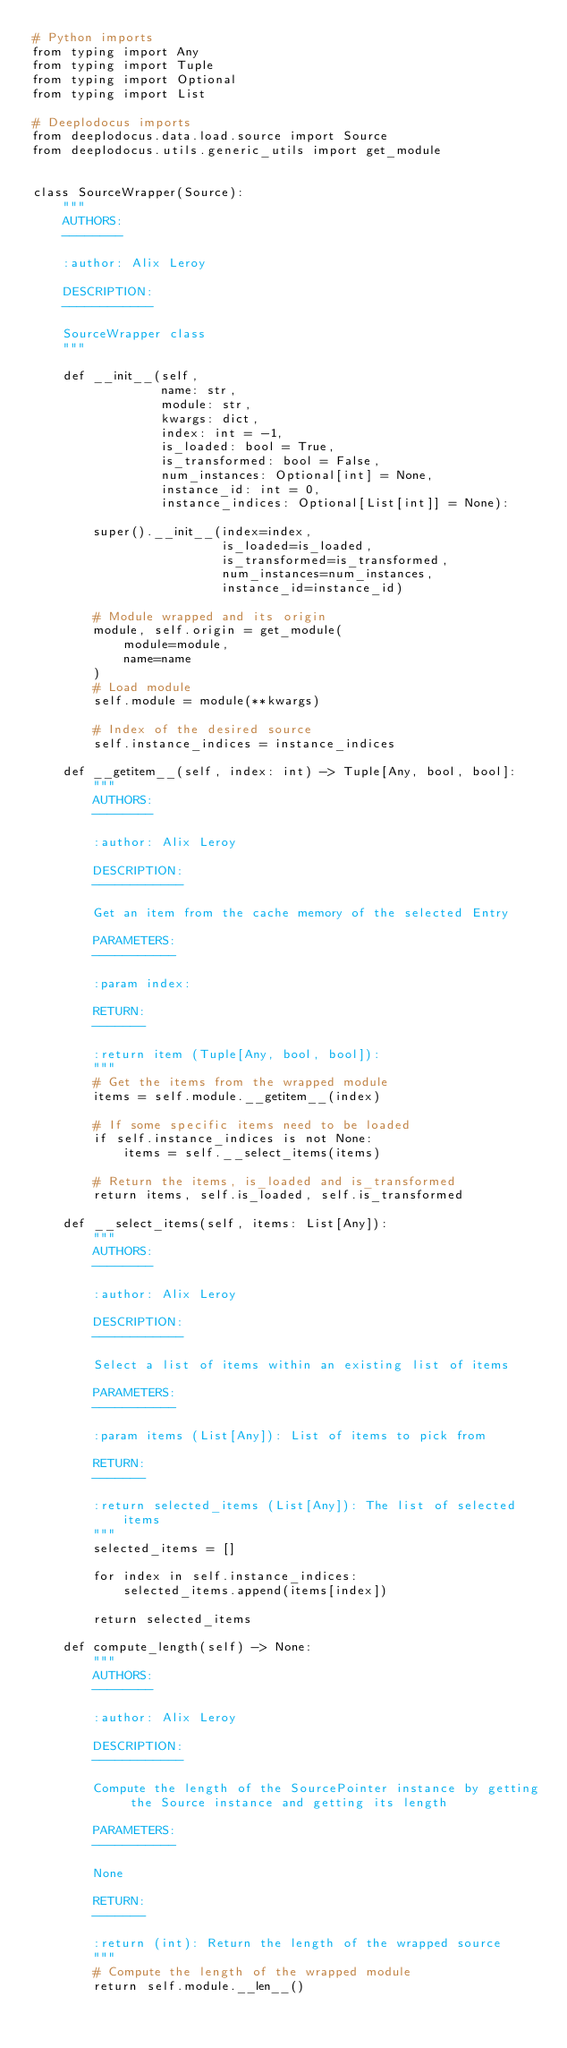<code> <loc_0><loc_0><loc_500><loc_500><_Python_># Python imports
from typing import Any
from typing import Tuple
from typing import Optional
from typing import List

# Deeplodocus imports
from deeplodocus.data.load.source import Source
from deeplodocus.utils.generic_utils import get_module


class SourceWrapper(Source):
    """
    AUTHORS:
    --------

    :author: Alix Leroy

    DESCRIPTION:
    ------------

    SourceWrapper class
    """

    def __init__(self,
                 name: str,
                 module: str,
                 kwargs: dict,
                 index: int = -1,
                 is_loaded: bool = True,
                 is_transformed: bool = False,
                 num_instances: Optional[int] = None,
                 instance_id: int = 0,
                 instance_indices: Optional[List[int]] = None):

        super().__init__(index=index,
                         is_loaded=is_loaded,
                         is_transformed=is_transformed,
                         num_instances=num_instances,
                         instance_id=instance_id)

        # Module wrapped and its origin
        module, self.origin = get_module(
            module=module,
            name=name
        )
        # Load module
        self.module = module(**kwargs)

        # Index of the desired source
        self.instance_indices = instance_indices

    def __getitem__(self, index: int) -> Tuple[Any, bool, bool]:
        """
        AUTHORS:
        --------

        :author: Alix Leroy

        DESCRIPTION:
        ------------

        Get an item from the cache memory of the selected Entry

        PARAMETERS:
        -----------

        :param index:

        RETURN:
        -------

        :return item (Tuple[Any, bool, bool]):
        """
        # Get the items from the wrapped module
        items = self.module.__getitem__(index)

        # If some specific items need to be loaded
        if self.instance_indices is not None:
            items = self.__select_items(items)

        # Return the items, is_loaded and is_transformed
        return items, self.is_loaded, self.is_transformed

    def __select_items(self, items: List[Any]):
        """
        AUTHORS:
        --------

        :author: Alix Leroy

        DESCRIPTION:
        ------------

        Select a list of items within an existing list of items

        PARAMETERS:
        -----------

        :param items (List[Any]): List of items to pick from

        RETURN:
        -------

        :return selected_items (List[Any]): The list of selected items
        """
        selected_items = []

        for index in self.instance_indices:
            selected_items.append(items[index])

        return selected_items

    def compute_length(self) -> None:
        """
        AUTHORS:
        --------

        :author: Alix Leroy

        DESCRIPTION:
        ------------

        Compute the length of the SourcePointer instance by getting the Source instance and getting its length

        PARAMETERS:
        -----------

        None

        RETURN:
        -------

        :return (int): Return the length of the wrapped source
        """
        # Compute the length of the wrapped module
        return self.module.__len__()
</code> 